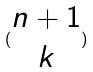<formula> <loc_0><loc_0><loc_500><loc_500>( \begin{matrix} n + 1 \\ k \end{matrix} )</formula> 